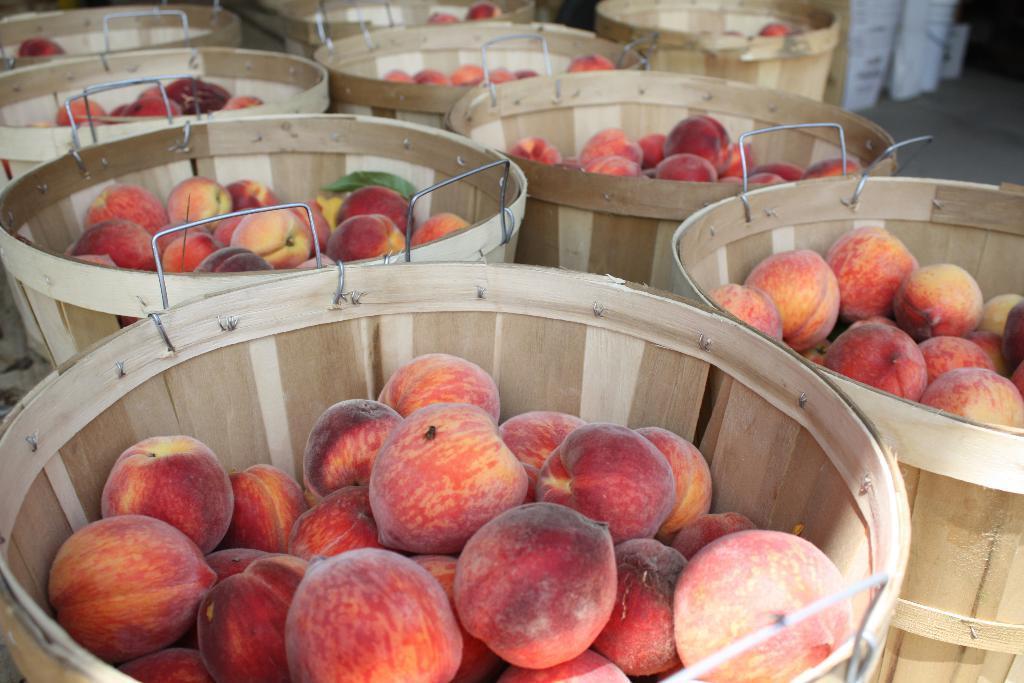How would you summarize this image in a sentence or two? In this image there are so many wooden baskets in which there are so many apples. 